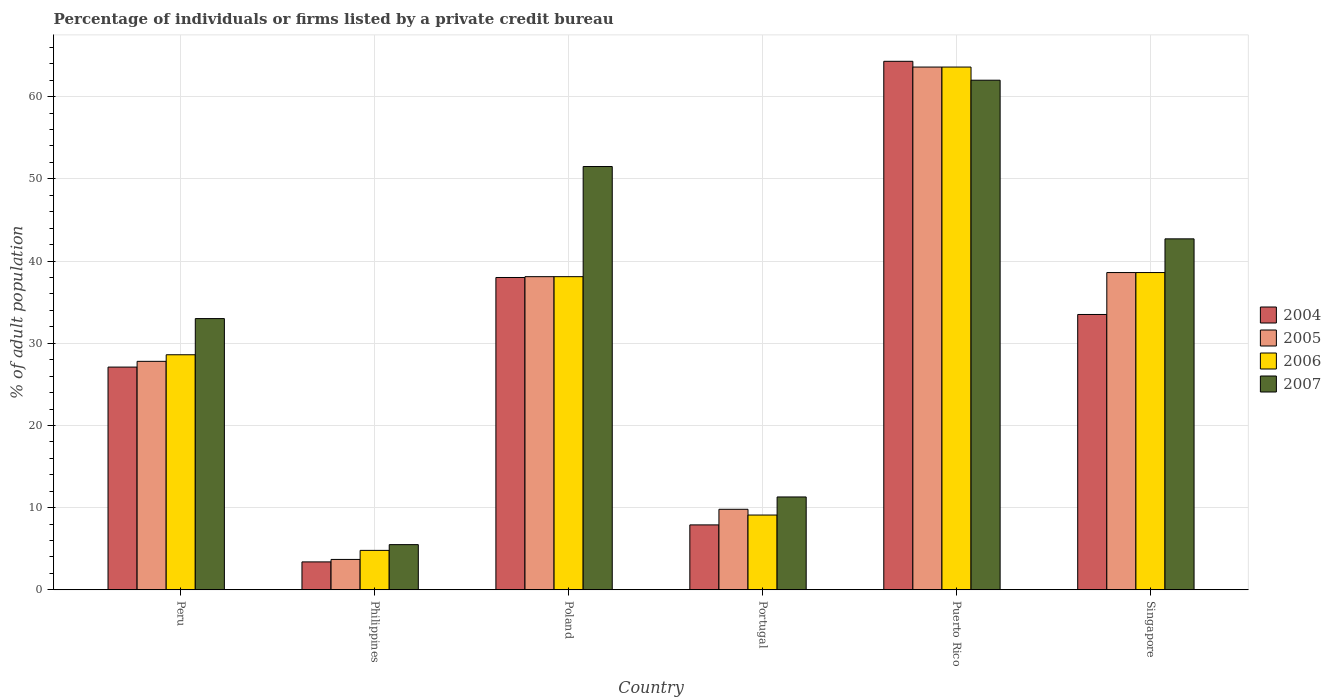Are the number of bars on each tick of the X-axis equal?
Provide a succinct answer. Yes. How many bars are there on the 6th tick from the left?
Offer a very short reply. 4. How many bars are there on the 2nd tick from the right?
Give a very brief answer. 4. In how many cases, is the number of bars for a given country not equal to the number of legend labels?
Offer a terse response. 0. What is the percentage of population listed by a private credit bureau in 2005 in Peru?
Offer a terse response. 27.8. Across all countries, what is the maximum percentage of population listed by a private credit bureau in 2006?
Offer a terse response. 63.6. Across all countries, what is the minimum percentage of population listed by a private credit bureau in 2007?
Your answer should be very brief. 5.5. In which country was the percentage of population listed by a private credit bureau in 2004 maximum?
Keep it short and to the point. Puerto Rico. In which country was the percentage of population listed by a private credit bureau in 2006 minimum?
Make the answer very short. Philippines. What is the total percentage of population listed by a private credit bureau in 2005 in the graph?
Ensure brevity in your answer.  181.6. What is the difference between the percentage of population listed by a private credit bureau in 2007 in Poland and that in Portugal?
Provide a succinct answer. 40.2. What is the difference between the percentage of population listed by a private credit bureau in 2006 in Portugal and the percentage of population listed by a private credit bureau in 2004 in Poland?
Your response must be concise. -28.9. What is the average percentage of population listed by a private credit bureau in 2006 per country?
Provide a succinct answer. 30.47. What is the difference between the percentage of population listed by a private credit bureau of/in 2004 and percentage of population listed by a private credit bureau of/in 2007 in Singapore?
Offer a very short reply. -9.2. In how many countries, is the percentage of population listed by a private credit bureau in 2004 greater than 50 %?
Your answer should be very brief. 1. What is the ratio of the percentage of population listed by a private credit bureau in 2006 in Portugal to that in Puerto Rico?
Provide a succinct answer. 0.14. Is the difference between the percentage of population listed by a private credit bureau in 2004 in Portugal and Puerto Rico greater than the difference between the percentage of population listed by a private credit bureau in 2007 in Portugal and Puerto Rico?
Give a very brief answer. No. What is the difference between the highest and the second highest percentage of population listed by a private credit bureau in 2004?
Offer a terse response. 30.8. What is the difference between the highest and the lowest percentage of population listed by a private credit bureau in 2007?
Keep it short and to the point. 56.5. In how many countries, is the percentage of population listed by a private credit bureau in 2007 greater than the average percentage of population listed by a private credit bureau in 2007 taken over all countries?
Give a very brief answer. 3. Is it the case that in every country, the sum of the percentage of population listed by a private credit bureau in 2006 and percentage of population listed by a private credit bureau in 2004 is greater than the sum of percentage of population listed by a private credit bureau in 2005 and percentage of population listed by a private credit bureau in 2007?
Offer a very short reply. No. What does the 1st bar from the left in Singapore represents?
Give a very brief answer. 2004. How many bars are there?
Your answer should be compact. 24. Are all the bars in the graph horizontal?
Your response must be concise. No. Are the values on the major ticks of Y-axis written in scientific E-notation?
Offer a terse response. No. Does the graph contain grids?
Your response must be concise. Yes. What is the title of the graph?
Your answer should be very brief. Percentage of individuals or firms listed by a private credit bureau. Does "1971" appear as one of the legend labels in the graph?
Give a very brief answer. No. What is the label or title of the X-axis?
Keep it short and to the point. Country. What is the label or title of the Y-axis?
Provide a short and direct response. % of adult population. What is the % of adult population in 2004 in Peru?
Offer a terse response. 27.1. What is the % of adult population of 2005 in Peru?
Your answer should be very brief. 27.8. What is the % of adult population of 2006 in Peru?
Your answer should be very brief. 28.6. What is the % of adult population in 2004 in Philippines?
Your answer should be very brief. 3.4. What is the % of adult population of 2005 in Philippines?
Ensure brevity in your answer.  3.7. What is the % of adult population of 2006 in Philippines?
Offer a very short reply. 4.8. What is the % of adult population in 2007 in Philippines?
Your response must be concise. 5.5. What is the % of adult population in 2005 in Poland?
Your response must be concise. 38.1. What is the % of adult population in 2006 in Poland?
Provide a short and direct response. 38.1. What is the % of adult population in 2007 in Poland?
Provide a succinct answer. 51.5. What is the % of adult population of 2005 in Portugal?
Keep it short and to the point. 9.8. What is the % of adult population of 2004 in Puerto Rico?
Make the answer very short. 64.3. What is the % of adult population in 2005 in Puerto Rico?
Offer a very short reply. 63.6. What is the % of adult population in 2006 in Puerto Rico?
Your answer should be very brief. 63.6. What is the % of adult population of 2004 in Singapore?
Give a very brief answer. 33.5. What is the % of adult population of 2005 in Singapore?
Your answer should be very brief. 38.6. What is the % of adult population in 2006 in Singapore?
Keep it short and to the point. 38.6. What is the % of adult population in 2007 in Singapore?
Give a very brief answer. 42.7. Across all countries, what is the maximum % of adult population in 2004?
Provide a short and direct response. 64.3. Across all countries, what is the maximum % of adult population in 2005?
Give a very brief answer. 63.6. Across all countries, what is the maximum % of adult population of 2006?
Make the answer very short. 63.6. Across all countries, what is the maximum % of adult population of 2007?
Your response must be concise. 62. Across all countries, what is the minimum % of adult population of 2004?
Keep it short and to the point. 3.4. Across all countries, what is the minimum % of adult population in 2005?
Offer a very short reply. 3.7. Across all countries, what is the minimum % of adult population of 2006?
Offer a very short reply. 4.8. What is the total % of adult population of 2004 in the graph?
Offer a very short reply. 174.2. What is the total % of adult population of 2005 in the graph?
Your response must be concise. 181.6. What is the total % of adult population in 2006 in the graph?
Provide a succinct answer. 182.8. What is the total % of adult population of 2007 in the graph?
Your answer should be compact. 206. What is the difference between the % of adult population of 2004 in Peru and that in Philippines?
Offer a terse response. 23.7. What is the difference between the % of adult population of 2005 in Peru and that in Philippines?
Provide a succinct answer. 24.1. What is the difference between the % of adult population in 2006 in Peru and that in Philippines?
Offer a terse response. 23.8. What is the difference between the % of adult population of 2007 in Peru and that in Philippines?
Your answer should be compact. 27.5. What is the difference between the % of adult population of 2007 in Peru and that in Poland?
Ensure brevity in your answer.  -18.5. What is the difference between the % of adult population of 2004 in Peru and that in Portugal?
Keep it short and to the point. 19.2. What is the difference between the % of adult population of 2007 in Peru and that in Portugal?
Provide a short and direct response. 21.7. What is the difference between the % of adult population in 2004 in Peru and that in Puerto Rico?
Ensure brevity in your answer.  -37.2. What is the difference between the % of adult population of 2005 in Peru and that in Puerto Rico?
Offer a very short reply. -35.8. What is the difference between the % of adult population of 2006 in Peru and that in Puerto Rico?
Provide a short and direct response. -35. What is the difference between the % of adult population in 2005 in Peru and that in Singapore?
Your answer should be very brief. -10.8. What is the difference between the % of adult population in 2006 in Peru and that in Singapore?
Provide a succinct answer. -10. What is the difference between the % of adult population of 2004 in Philippines and that in Poland?
Give a very brief answer. -34.6. What is the difference between the % of adult population of 2005 in Philippines and that in Poland?
Offer a very short reply. -34.4. What is the difference between the % of adult population in 2006 in Philippines and that in Poland?
Ensure brevity in your answer.  -33.3. What is the difference between the % of adult population of 2007 in Philippines and that in Poland?
Make the answer very short. -46. What is the difference between the % of adult population in 2005 in Philippines and that in Portugal?
Your answer should be compact. -6.1. What is the difference between the % of adult population of 2007 in Philippines and that in Portugal?
Make the answer very short. -5.8. What is the difference between the % of adult population of 2004 in Philippines and that in Puerto Rico?
Provide a succinct answer. -60.9. What is the difference between the % of adult population of 2005 in Philippines and that in Puerto Rico?
Your response must be concise. -59.9. What is the difference between the % of adult population in 2006 in Philippines and that in Puerto Rico?
Your answer should be very brief. -58.8. What is the difference between the % of adult population in 2007 in Philippines and that in Puerto Rico?
Your response must be concise. -56.5. What is the difference between the % of adult population of 2004 in Philippines and that in Singapore?
Ensure brevity in your answer.  -30.1. What is the difference between the % of adult population in 2005 in Philippines and that in Singapore?
Your response must be concise. -34.9. What is the difference between the % of adult population of 2006 in Philippines and that in Singapore?
Offer a very short reply. -33.8. What is the difference between the % of adult population of 2007 in Philippines and that in Singapore?
Your response must be concise. -37.2. What is the difference between the % of adult population of 2004 in Poland and that in Portugal?
Keep it short and to the point. 30.1. What is the difference between the % of adult population in 2005 in Poland and that in Portugal?
Provide a succinct answer. 28.3. What is the difference between the % of adult population in 2006 in Poland and that in Portugal?
Give a very brief answer. 29. What is the difference between the % of adult population in 2007 in Poland and that in Portugal?
Your response must be concise. 40.2. What is the difference between the % of adult population in 2004 in Poland and that in Puerto Rico?
Your response must be concise. -26.3. What is the difference between the % of adult population of 2005 in Poland and that in Puerto Rico?
Your response must be concise. -25.5. What is the difference between the % of adult population in 2006 in Poland and that in Puerto Rico?
Offer a terse response. -25.5. What is the difference between the % of adult population of 2007 in Poland and that in Puerto Rico?
Ensure brevity in your answer.  -10.5. What is the difference between the % of adult population of 2004 in Poland and that in Singapore?
Offer a terse response. 4.5. What is the difference between the % of adult population in 2007 in Poland and that in Singapore?
Make the answer very short. 8.8. What is the difference between the % of adult population in 2004 in Portugal and that in Puerto Rico?
Your response must be concise. -56.4. What is the difference between the % of adult population in 2005 in Portugal and that in Puerto Rico?
Provide a short and direct response. -53.8. What is the difference between the % of adult population of 2006 in Portugal and that in Puerto Rico?
Provide a short and direct response. -54.5. What is the difference between the % of adult population in 2007 in Portugal and that in Puerto Rico?
Keep it short and to the point. -50.7. What is the difference between the % of adult population in 2004 in Portugal and that in Singapore?
Your answer should be very brief. -25.6. What is the difference between the % of adult population of 2005 in Portugal and that in Singapore?
Your answer should be compact. -28.8. What is the difference between the % of adult population in 2006 in Portugal and that in Singapore?
Your answer should be compact. -29.5. What is the difference between the % of adult population in 2007 in Portugal and that in Singapore?
Ensure brevity in your answer.  -31.4. What is the difference between the % of adult population of 2004 in Puerto Rico and that in Singapore?
Keep it short and to the point. 30.8. What is the difference between the % of adult population of 2006 in Puerto Rico and that in Singapore?
Your answer should be compact. 25. What is the difference between the % of adult population of 2007 in Puerto Rico and that in Singapore?
Offer a very short reply. 19.3. What is the difference between the % of adult population of 2004 in Peru and the % of adult population of 2005 in Philippines?
Provide a short and direct response. 23.4. What is the difference between the % of adult population in 2004 in Peru and the % of adult population in 2006 in Philippines?
Your response must be concise. 22.3. What is the difference between the % of adult population in 2004 in Peru and the % of adult population in 2007 in Philippines?
Your answer should be compact. 21.6. What is the difference between the % of adult population in 2005 in Peru and the % of adult population in 2006 in Philippines?
Your response must be concise. 23. What is the difference between the % of adult population of 2005 in Peru and the % of adult population of 2007 in Philippines?
Your answer should be very brief. 22.3. What is the difference between the % of adult population in 2006 in Peru and the % of adult population in 2007 in Philippines?
Offer a terse response. 23.1. What is the difference between the % of adult population in 2004 in Peru and the % of adult population in 2007 in Poland?
Provide a short and direct response. -24.4. What is the difference between the % of adult population of 2005 in Peru and the % of adult population of 2007 in Poland?
Provide a short and direct response. -23.7. What is the difference between the % of adult population in 2006 in Peru and the % of adult population in 2007 in Poland?
Provide a short and direct response. -22.9. What is the difference between the % of adult population of 2004 in Peru and the % of adult population of 2005 in Portugal?
Offer a terse response. 17.3. What is the difference between the % of adult population of 2004 in Peru and the % of adult population of 2006 in Portugal?
Offer a terse response. 18. What is the difference between the % of adult population in 2004 in Peru and the % of adult population in 2007 in Portugal?
Provide a short and direct response. 15.8. What is the difference between the % of adult population in 2004 in Peru and the % of adult population in 2005 in Puerto Rico?
Offer a very short reply. -36.5. What is the difference between the % of adult population of 2004 in Peru and the % of adult population of 2006 in Puerto Rico?
Provide a succinct answer. -36.5. What is the difference between the % of adult population in 2004 in Peru and the % of adult population in 2007 in Puerto Rico?
Make the answer very short. -34.9. What is the difference between the % of adult population in 2005 in Peru and the % of adult population in 2006 in Puerto Rico?
Offer a very short reply. -35.8. What is the difference between the % of adult population in 2005 in Peru and the % of adult population in 2007 in Puerto Rico?
Provide a short and direct response. -34.2. What is the difference between the % of adult population in 2006 in Peru and the % of adult population in 2007 in Puerto Rico?
Keep it short and to the point. -33.4. What is the difference between the % of adult population of 2004 in Peru and the % of adult population of 2005 in Singapore?
Your answer should be compact. -11.5. What is the difference between the % of adult population in 2004 in Peru and the % of adult population in 2007 in Singapore?
Keep it short and to the point. -15.6. What is the difference between the % of adult population in 2005 in Peru and the % of adult population in 2007 in Singapore?
Offer a very short reply. -14.9. What is the difference between the % of adult population in 2006 in Peru and the % of adult population in 2007 in Singapore?
Keep it short and to the point. -14.1. What is the difference between the % of adult population of 2004 in Philippines and the % of adult population of 2005 in Poland?
Your answer should be compact. -34.7. What is the difference between the % of adult population in 2004 in Philippines and the % of adult population in 2006 in Poland?
Your answer should be compact. -34.7. What is the difference between the % of adult population of 2004 in Philippines and the % of adult population of 2007 in Poland?
Your answer should be very brief. -48.1. What is the difference between the % of adult population of 2005 in Philippines and the % of adult population of 2006 in Poland?
Provide a short and direct response. -34.4. What is the difference between the % of adult population of 2005 in Philippines and the % of adult population of 2007 in Poland?
Offer a very short reply. -47.8. What is the difference between the % of adult population of 2006 in Philippines and the % of adult population of 2007 in Poland?
Your response must be concise. -46.7. What is the difference between the % of adult population in 2004 in Philippines and the % of adult population in 2006 in Portugal?
Keep it short and to the point. -5.7. What is the difference between the % of adult population in 2006 in Philippines and the % of adult population in 2007 in Portugal?
Your answer should be very brief. -6.5. What is the difference between the % of adult population in 2004 in Philippines and the % of adult population in 2005 in Puerto Rico?
Provide a short and direct response. -60.2. What is the difference between the % of adult population of 2004 in Philippines and the % of adult population of 2006 in Puerto Rico?
Offer a very short reply. -60.2. What is the difference between the % of adult population of 2004 in Philippines and the % of adult population of 2007 in Puerto Rico?
Keep it short and to the point. -58.6. What is the difference between the % of adult population of 2005 in Philippines and the % of adult population of 2006 in Puerto Rico?
Your answer should be compact. -59.9. What is the difference between the % of adult population of 2005 in Philippines and the % of adult population of 2007 in Puerto Rico?
Give a very brief answer. -58.3. What is the difference between the % of adult population of 2006 in Philippines and the % of adult population of 2007 in Puerto Rico?
Make the answer very short. -57.2. What is the difference between the % of adult population in 2004 in Philippines and the % of adult population in 2005 in Singapore?
Your answer should be very brief. -35.2. What is the difference between the % of adult population of 2004 in Philippines and the % of adult population of 2006 in Singapore?
Ensure brevity in your answer.  -35.2. What is the difference between the % of adult population of 2004 in Philippines and the % of adult population of 2007 in Singapore?
Provide a succinct answer. -39.3. What is the difference between the % of adult population in 2005 in Philippines and the % of adult population in 2006 in Singapore?
Your response must be concise. -34.9. What is the difference between the % of adult population in 2005 in Philippines and the % of adult population in 2007 in Singapore?
Your answer should be very brief. -39. What is the difference between the % of adult population of 2006 in Philippines and the % of adult population of 2007 in Singapore?
Make the answer very short. -37.9. What is the difference between the % of adult population of 2004 in Poland and the % of adult population of 2005 in Portugal?
Your response must be concise. 28.2. What is the difference between the % of adult population in 2004 in Poland and the % of adult population in 2006 in Portugal?
Offer a very short reply. 28.9. What is the difference between the % of adult population in 2004 in Poland and the % of adult population in 2007 in Portugal?
Your response must be concise. 26.7. What is the difference between the % of adult population in 2005 in Poland and the % of adult population in 2006 in Portugal?
Offer a very short reply. 29. What is the difference between the % of adult population in 2005 in Poland and the % of adult population in 2007 in Portugal?
Offer a terse response. 26.8. What is the difference between the % of adult population of 2006 in Poland and the % of adult population of 2007 in Portugal?
Your response must be concise. 26.8. What is the difference between the % of adult population of 2004 in Poland and the % of adult population of 2005 in Puerto Rico?
Your answer should be very brief. -25.6. What is the difference between the % of adult population of 2004 in Poland and the % of adult population of 2006 in Puerto Rico?
Make the answer very short. -25.6. What is the difference between the % of adult population of 2004 in Poland and the % of adult population of 2007 in Puerto Rico?
Ensure brevity in your answer.  -24. What is the difference between the % of adult population of 2005 in Poland and the % of adult population of 2006 in Puerto Rico?
Your answer should be very brief. -25.5. What is the difference between the % of adult population in 2005 in Poland and the % of adult population in 2007 in Puerto Rico?
Provide a short and direct response. -23.9. What is the difference between the % of adult population in 2006 in Poland and the % of adult population in 2007 in Puerto Rico?
Your answer should be compact. -23.9. What is the difference between the % of adult population of 2004 in Poland and the % of adult population of 2006 in Singapore?
Make the answer very short. -0.6. What is the difference between the % of adult population in 2004 in Poland and the % of adult population in 2007 in Singapore?
Make the answer very short. -4.7. What is the difference between the % of adult population in 2005 in Poland and the % of adult population in 2006 in Singapore?
Keep it short and to the point. -0.5. What is the difference between the % of adult population in 2005 in Poland and the % of adult population in 2007 in Singapore?
Give a very brief answer. -4.6. What is the difference between the % of adult population of 2004 in Portugal and the % of adult population of 2005 in Puerto Rico?
Keep it short and to the point. -55.7. What is the difference between the % of adult population of 2004 in Portugal and the % of adult population of 2006 in Puerto Rico?
Your answer should be compact. -55.7. What is the difference between the % of adult population in 2004 in Portugal and the % of adult population in 2007 in Puerto Rico?
Ensure brevity in your answer.  -54.1. What is the difference between the % of adult population of 2005 in Portugal and the % of adult population of 2006 in Puerto Rico?
Your answer should be compact. -53.8. What is the difference between the % of adult population in 2005 in Portugal and the % of adult population in 2007 in Puerto Rico?
Your answer should be compact. -52.2. What is the difference between the % of adult population in 2006 in Portugal and the % of adult population in 2007 in Puerto Rico?
Provide a short and direct response. -52.9. What is the difference between the % of adult population of 2004 in Portugal and the % of adult population of 2005 in Singapore?
Ensure brevity in your answer.  -30.7. What is the difference between the % of adult population of 2004 in Portugal and the % of adult population of 2006 in Singapore?
Keep it short and to the point. -30.7. What is the difference between the % of adult population of 2004 in Portugal and the % of adult population of 2007 in Singapore?
Ensure brevity in your answer.  -34.8. What is the difference between the % of adult population in 2005 in Portugal and the % of adult population in 2006 in Singapore?
Make the answer very short. -28.8. What is the difference between the % of adult population of 2005 in Portugal and the % of adult population of 2007 in Singapore?
Make the answer very short. -32.9. What is the difference between the % of adult population in 2006 in Portugal and the % of adult population in 2007 in Singapore?
Your answer should be compact. -33.6. What is the difference between the % of adult population in 2004 in Puerto Rico and the % of adult population in 2005 in Singapore?
Your response must be concise. 25.7. What is the difference between the % of adult population of 2004 in Puerto Rico and the % of adult population of 2006 in Singapore?
Provide a short and direct response. 25.7. What is the difference between the % of adult population of 2004 in Puerto Rico and the % of adult population of 2007 in Singapore?
Your response must be concise. 21.6. What is the difference between the % of adult population of 2005 in Puerto Rico and the % of adult population of 2007 in Singapore?
Offer a very short reply. 20.9. What is the difference between the % of adult population of 2006 in Puerto Rico and the % of adult population of 2007 in Singapore?
Offer a very short reply. 20.9. What is the average % of adult population of 2004 per country?
Offer a very short reply. 29.03. What is the average % of adult population in 2005 per country?
Your answer should be compact. 30.27. What is the average % of adult population of 2006 per country?
Provide a short and direct response. 30.47. What is the average % of adult population of 2007 per country?
Give a very brief answer. 34.33. What is the difference between the % of adult population in 2005 and % of adult population in 2006 in Peru?
Your answer should be compact. -0.8. What is the difference between the % of adult population in 2005 and % of adult population in 2006 in Philippines?
Offer a terse response. -1.1. What is the difference between the % of adult population of 2006 and % of adult population of 2007 in Philippines?
Offer a very short reply. -0.7. What is the difference between the % of adult population in 2004 and % of adult population in 2006 in Poland?
Your answer should be compact. -0.1. What is the difference between the % of adult population of 2004 and % of adult population of 2007 in Poland?
Offer a very short reply. -13.5. What is the difference between the % of adult population of 2005 and % of adult population of 2007 in Poland?
Your answer should be very brief. -13.4. What is the difference between the % of adult population in 2004 and % of adult population in 2005 in Portugal?
Provide a short and direct response. -1.9. What is the difference between the % of adult population of 2004 and % of adult population of 2006 in Portugal?
Ensure brevity in your answer.  -1.2. What is the difference between the % of adult population in 2004 and % of adult population in 2007 in Portugal?
Your answer should be compact. -3.4. What is the difference between the % of adult population in 2004 and % of adult population in 2005 in Puerto Rico?
Provide a succinct answer. 0.7. What is the difference between the % of adult population in 2006 and % of adult population in 2007 in Puerto Rico?
Provide a succinct answer. 1.6. What is the difference between the % of adult population in 2005 and % of adult population in 2006 in Singapore?
Provide a short and direct response. 0. What is the difference between the % of adult population of 2005 and % of adult population of 2007 in Singapore?
Provide a succinct answer. -4.1. What is the ratio of the % of adult population in 2004 in Peru to that in Philippines?
Your response must be concise. 7.97. What is the ratio of the % of adult population of 2005 in Peru to that in Philippines?
Make the answer very short. 7.51. What is the ratio of the % of adult population of 2006 in Peru to that in Philippines?
Offer a very short reply. 5.96. What is the ratio of the % of adult population in 2004 in Peru to that in Poland?
Provide a succinct answer. 0.71. What is the ratio of the % of adult population of 2005 in Peru to that in Poland?
Provide a succinct answer. 0.73. What is the ratio of the % of adult population of 2006 in Peru to that in Poland?
Your answer should be compact. 0.75. What is the ratio of the % of adult population in 2007 in Peru to that in Poland?
Ensure brevity in your answer.  0.64. What is the ratio of the % of adult population of 2004 in Peru to that in Portugal?
Your answer should be compact. 3.43. What is the ratio of the % of adult population of 2005 in Peru to that in Portugal?
Provide a short and direct response. 2.84. What is the ratio of the % of adult population of 2006 in Peru to that in Portugal?
Offer a very short reply. 3.14. What is the ratio of the % of adult population of 2007 in Peru to that in Portugal?
Offer a very short reply. 2.92. What is the ratio of the % of adult population in 2004 in Peru to that in Puerto Rico?
Make the answer very short. 0.42. What is the ratio of the % of adult population of 2005 in Peru to that in Puerto Rico?
Offer a terse response. 0.44. What is the ratio of the % of adult population of 2006 in Peru to that in Puerto Rico?
Offer a terse response. 0.45. What is the ratio of the % of adult population in 2007 in Peru to that in Puerto Rico?
Give a very brief answer. 0.53. What is the ratio of the % of adult population of 2004 in Peru to that in Singapore?
Make the answer very short. 0.81. What is the ratio of the % of adult population of 2005 in Peru to that in Singapore?
Make the answer very short. 0.72. What is the ratio of the % of adult population of 2006 in Peru to that in Singapore?
Give a very brief answer. 0.74. What is the ratio of the % of adult population in 2007 in Peru to that in Singapore?
Give a very brief answer. 0.77. What is the ratio of the % of adult population in 2004 in Philippines to that in Poland?
Offer a very short reply. 0.09. What is the ratio of the % of adult population of 2005 in Philippines to that in Poland?
Provide a succinct answer. 0.1. What is the ratio of the % of adult population in 2006 in Philippines to that in Poland?
Make the answer very short. 0.13. What is the ratio of the % of adult population in 2007 in Philippines to that in Poland?
Make the answer very short. 0.11. What is the ratio of the % of adult population in 2004 in Philippines to that in Portugal?
Ensure brevity in your answer.  0.43. What is the ratio of the % of adult population of 2005 in Philippines to that in Portugal?
Keep it short and to the point. 0.38. What is the ratio of the % of adult population of 2006 in Philippines to that in Portugal?
Offer a terse response. 0.53. What is the ratio of the % of adult population in 2007 in Philippines to that in Portugal?
Offer a very short reply. 0.49. What is the ratio of the % of adult population in 2004 in Philippines to that in Puerto Rico?
Your answer should be compact. 0.05. What is the ratio of the % of adult population in 2005 in Philippines to that in Puerto Rico?
Your answer should be compact. 0.06. What is the ratio of the % of adult population of 2006 in Philippines to that in Puerto Rico?
Ensure brevity in your answer.  0.08. What is the ratio of the % of adult population in 2007 in Philippines to that in Puerto Rico?
Your answer should be compact. 0.09. What is the ratio of the % of adult population of 2004 in Philippines to that in Singapore?
Your answer should be very brief. 0.1. What is the ratio of the % of adult population of 2005 in Philippines to that in Singapore?
Your answer should be very brief. 0.1. What is the ratio of the % of adult population in 2006 in Philippines to that in Singapore?
Give a very brief answer. 0.12. What is the ratio of the % of adult population of 2007 in Philippines to that in Singapore?
Your answer should be very brief. 0.13. What is the ratio of the % of adult population of 2004 in Poland to that in Portugal?
Offer a terse response. 4.81. What is the ratio of the % of adult population of 2005 in Poland to that in Portugal?
Ensure brevity in your answer.  3.89. What is the ratio of the % of adult population in 2006 in Poland to that in Portugal?
Your answer should be compact. 4.19. What is the ratio of the % of adult population of 2007 in Poland to that in Portugal?
Offer a terse response. 4.56. What is the ratio of the % of adult population of 2004 in Poland to that in Puerto Rico?
Offer a terse response. 0.59. What is the ratio of the % of adult population in 2005 in Poland to that in Puerto Rico?
Keep it short and to the point. 0.6. What is the ratio of the % of adult population of 2006 in Poland to that in Puerto Rico?
Keep it short and to the point. 0.6. What is the ratio of the % of adult population in 2007 in Poland to that in Puerto Rico?
Make the answer very short. 0.83. What is the ratio of the % of adult population of 2004 in Poland to that in Singapore?
Make the answer very short. 1.13. What is the ratio of the % of adult population of 2005 in Poland to that in Singapore?
Your response must be concise. 0.99. What is the ratio of the % of adult population in 2006 in Poland to that in Singapore?
Provide a short and direct response. 0.99. What is the ratio of the % of adult population in 2007 in Poland to that in Singapore?
Keep it short and to the point. 1.21. What is the ratio of the % of adult population of 2004 in Portugal to that in Puerto Rico?
Provide a short and direct response. 0.12. What is the ratio of the % of adult population in 2005 in Portugal to that in Puerto Rico?
Provide a short and direct response. 0.15. What is the ratio of the % of adult population of 2006 in Portugal to that in Puerto Rico?
Offer a terse response. 0.14. What is the ratio of the % of adult population in 2007 in Portugal to that in Puerto Rico?
Give a very brief answer. 0.18. What is the ratio of the % of adult population of 2004 in Portugal to that in Singapore?
Give a very brief answer. 0.24. What is the ratio of the % of adult population of 2005 in Portugal to that in Singapore?
Make the answer very short. 0.25. What is the ratio of the % of adult population of 2006 in Portugal to that in Singapore?
Your answer should be compact. 0.24. What is the ratio of the % of adult population in 2007 in Portugal to that in Singapore?
Provide a short and direct response. 0.26. What is the ratio of the % of adult population of 2004 in Puerto Rico to that in Singapore?
Ensure brevity in your answer.  1.92. What is the ratio of the % of adult population of 2005 in Puerto Rico to that in Singapore?
Provide a succinct answer. 1.65. What is the ratio of the % of adult population in 2006 in Puerto Rico to that in Singapore?
Your answer should be very brief. 1.65. What is the ratio of the % of adult population in 2007 in Puerto Rico to that in Singapore?
Ensure brevity in your answer.  1.45. What is the difference between the highest and the second highest % of adult population in 2004?
Offer a very short reply. 26.3. What is the difference between the highest and the second highest % of adult population in 2005?
Offer a terse response. 25. What is the difference between the highest and the second highest % of adult population of 2007?
Your answer should be compact. 10.5. What is the difference between the highest and the lowest % of adult population in 2004?
Your response must be concise. 60.9. What is the difference between the highest and the lowest % of adult population of 2005?
Your answer should be very brief. 59.9. What is the difference between the highest and the lowest % of adult population of 2006?
Make the answer very short. 58.8. What is the difference between the highest and the lowest % of adult population of 2007?
Provide a short and direct response. 56.5. 